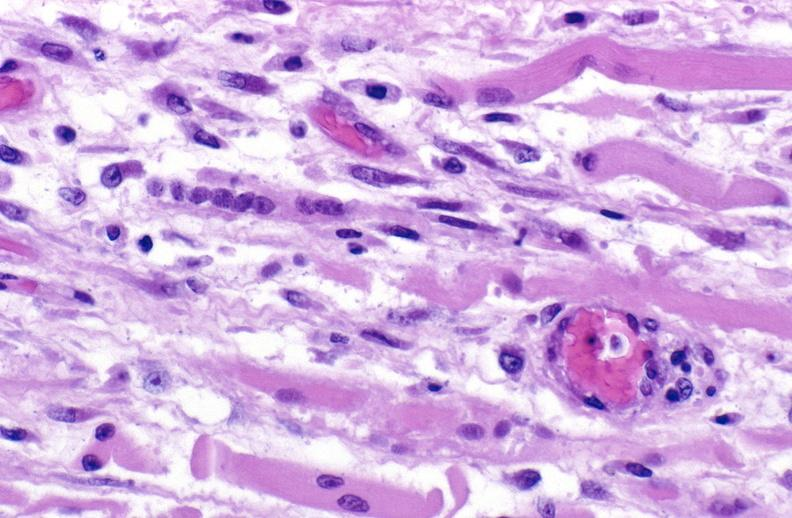does this image show tracheotomy site, granulation tissue?
Answer the question using a single word or phrase. Yes 